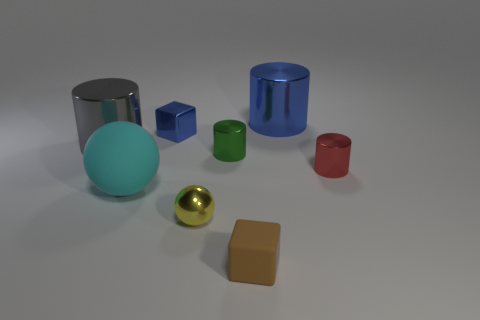Subtract all gray cylinders. How many cylinders are left? 3 Add 1 tiny green shiny cylinders. How many objects exist? 9 Subtract all blue cylinders. How many cylinders are left? 3 Subtract 2 cylinders. How many cylinders are left? 2 Subtract all spheres. How many objects are left? 6 Subtract all small brown things. Subtract all matte spheres. How many objects are left? 6 Add 8 tiny green cylinders. How many tiny green cylinders are left? 9 Add 6 rubber spheres. How many rubber spheres exist? 7 Subtract 1 yellow spheres. How many objects are left? 7 Subtract all purple blocks. Subtract all blue balls. How many blocks are left? 2 